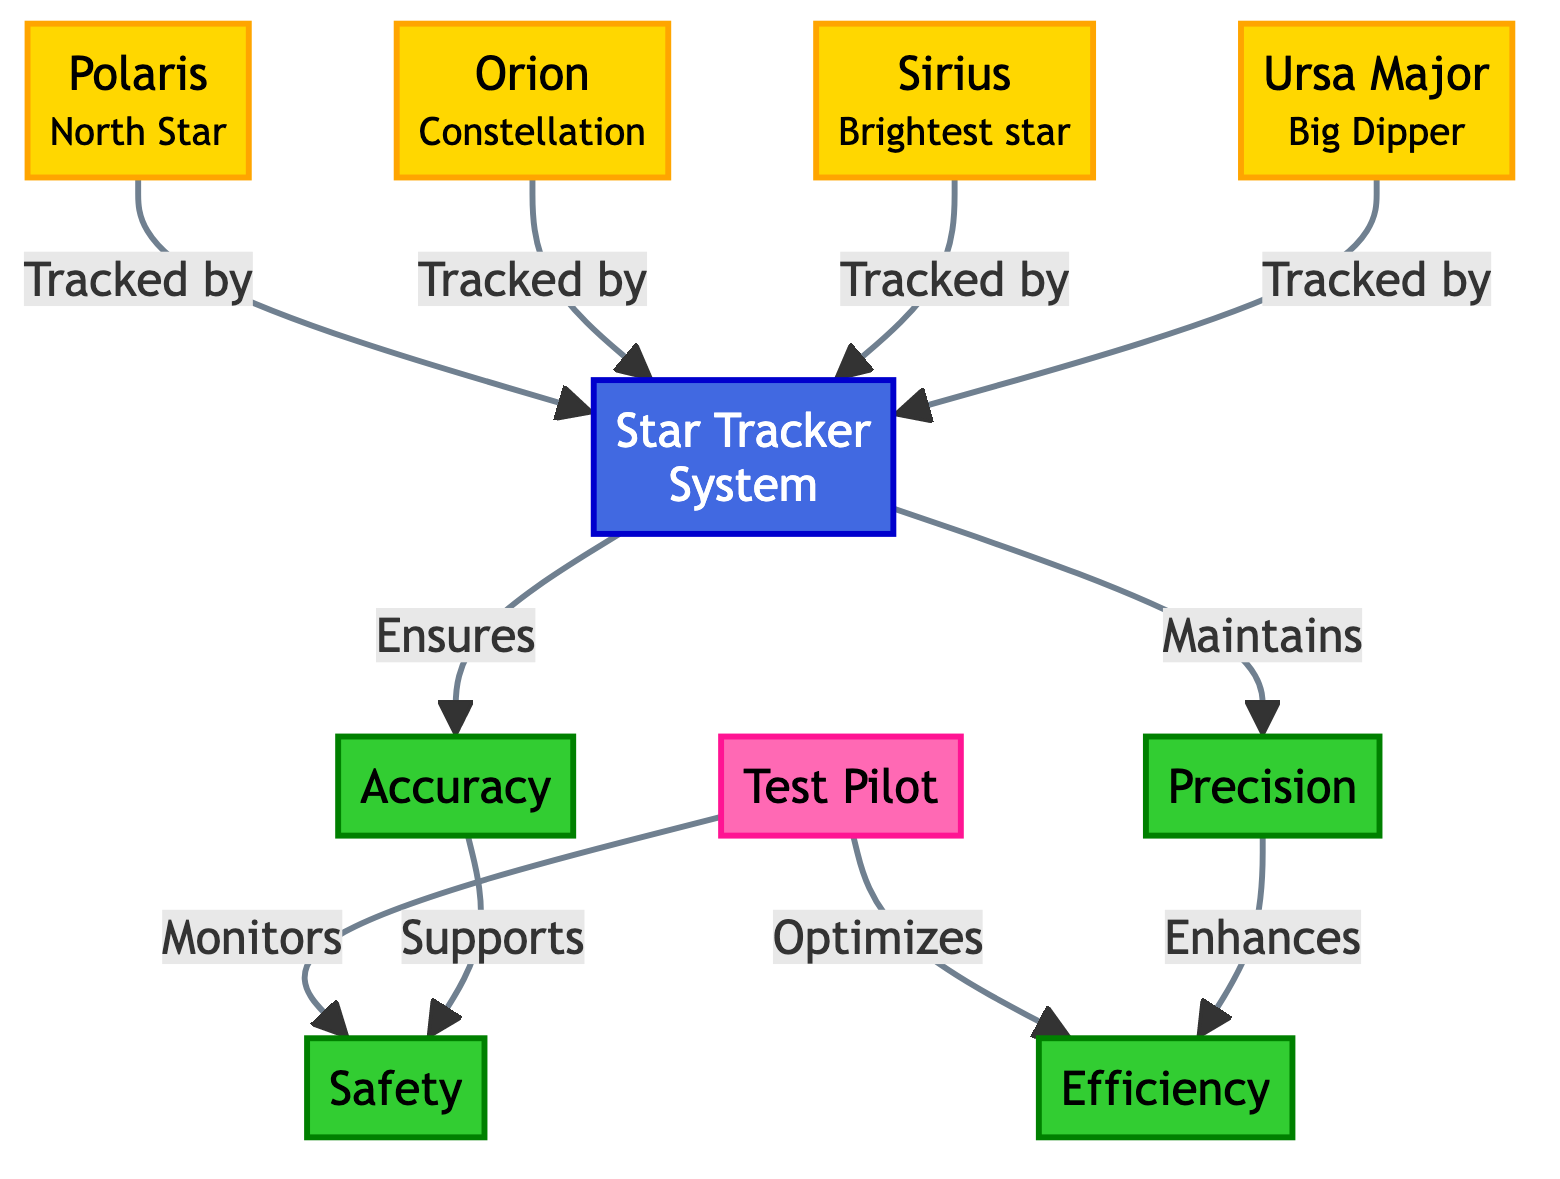What is the North Star represented in the diagram? The diagram shows "Polaris" as the representation of the North Star. This is directly indicated in the diagram next to the node labeled "Polaris."
Answer: Polaris How many celestial objects are tracked by the Star Tracker System? The diagram lists four celestial objects: Polaris, Orion, Sirius, and Ursa Major. By counting these nodes connected to the Star Tracker System, the total is four.
Answer: 4 Which attribute does the Star Tracker System ensure? The diagram indicates that the Star Tracker System ensures "Accuracy." This is explicitly stated in the connection flow from the Star Tracker System node to the Accuracy attribute node.
Answer: Accuracy What relationship does "Orion" have with the Star Tracker System? The diagram shows that "Orion" is tracked by the Star Tracker System. This connection is clearly illustrated by an arrow leading from Orion to the Star Tracker System node.
Answer: Tracked by How does the "Test Pilot" influence "Safety"? The diagram indicates that the Test Pilot monitors "Safety," which directly connects the two nodes. This means the Test Pilot's role is to oversee aspects that contribute to safety during flight testing.
Answer: Monitors What are the two attributes associated with the Star Tracker System? The diagram illustrates two attributes: "Accuracy" and "Precision." These are directly linked to the Star Tracker System node and are part of the overall functionality it provides.
Answer: Accuracy, Precision Why is "Precision" important in relation to "Efficiency"? The diagram shows that "Precision" enhances "Efficiency." This means that maintaining precision in navigational data allows for improved efficiency in flight testing processes, linking both concepts closely.
Answer: Enhances Which constellation is noted as the "Brightest star"? Within the diagram, "Sirius" is specifically identified with the label "Brightest star." This is directly mentioned next to the Sirius node in the diagram.
Answer: Sirius What is the color scheme for the stars in the diagram? The stars in the diagram are represented with a color scheme defined by classDef, specifically a fill color of gold (`fill:#FFD700`). This is applicable to all the star nodes in the diagram.
Answer: Gold 